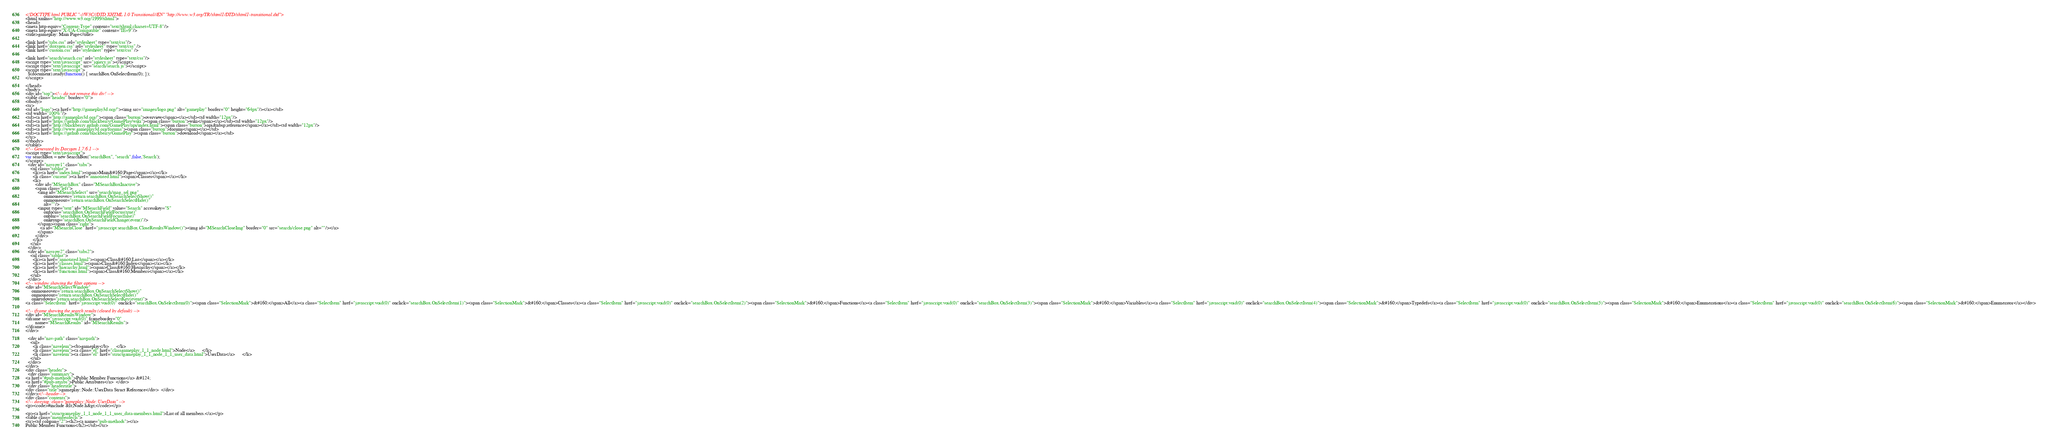Convert code to text. <code><loc_0><loc_0><loc_500><loc_500><_HTML_><!DOCTYPE html PUBLIC "-//W3C//DTD XHTML 1.0 Transitional//EN" "http://www.w3.org/TR/xhtml1/DTD/xhtml1-transitional.dtd">
<html xmlns="http://www.w3.org/1999/xhtml">
<head>
<meta http-equiv="Content-Type" content="text/xhtml;charset=UTF-8"/>
<meta http-equiv="X-UA-Compatible" content="IE=9"/>
<title>gameplay: Main Page</title>

<link href="tabs.css" rel="stylesheet" type="text/css"/>
<link href="doxygen.css" rel="stylesheet" type="text/css" />
<link href="custom.css" rel="stylesheet" type="text/css" />

<link href="search/search.css" rel="stylesheet" type="text/css"/>
<script type="text/javascript" src="jquery.js"></script>
<script type="text/javascript" src="search/search.js"></script>
<script type="text/javascript">
  $(document).ready(function() { searchBox.OnSelectItem(0); });
</script>

</head>
<body>
<div id="top"><!-- do not remove this div! -->
<table class="header" border="0">
<tbody>
<tr>
<td id="logo"><a href="http://gameplay3d.org/"><img src="images/logo.png" alt="gameplay" border="0" height="64px"/></a></td>
<td width="100%"/>
<td><a href="http://gameplay3d.org/"><span class="button">overview</span></a></td><td width="12px"/>
<td><a href="https://github.com/blackberry/GamePlay/wiki"><span class="button">wiki</span></a></td><td width="12px"/>
<td><a href="http://blackberry.github.com/GamePlay/api/index.html"><span class="button">api&nbsp;reference</span></a></td><td width="12px"/>
<td><a href="http://www.gameplay3d.org/forums"><span class="button">forums</span></a></td>
<td><a href="https://github.com/blackberry/GamePlay"><span class="button">download</span></a></td>
</tr>
</tbody>
</table>
<!-- Generated by Doxygen 1.7.6.1 -->
<script type="text/javascript">
var searchBox = new SearchBox("searchBox", "search",false,'Search');
</script>
  <div id="navrow1" class="tabs">
    <ul class="tablist">
      <li><a href="index.html"><span>Main&#160;Page</span></a></li>
      <li class="current"><a href="annotated.html"><span>Classes</span></a></li>
      <li>
        <div id="MSearchBox" class="MSearchBoxInactive">
        <span class="left">
          <img id="MSearchSelect" src="search/mag_sel.png"
               onmouseover="return searchBox.OnSearchSelectShow()"
               onmouseout="return searchBox.OnSearchSelectHide()"
               alt=""/>
          <input type="text" id="MSearchField" value="Search" accesskey="S"
               onfocus="searchBox.OnSearchFieldFocus(true)" 
               onblur="searchBox.OnSearchFieldFocus(false)" 
               onkeyup="searchBox.OnSearchFieldChange(event)"/>
          </span><span class="right">
            <a id="MSearchClose" href="javascript:searchBox.CloseResultsWindow()"><img id="MSearchCloseImg" border="0" src="search/close.png" alt=""/></a>
          </span>
        </div>
      </li>
    </ul>
  </div>
  <div id="navrow2" class="tabs2">
    <ul class="tablist">
      <li><a href="annotated.html"><span>Class&#160;List</span></a></li>
      <li><a href="classes.html"><span>Class&#160;Index</span></a></li>
      <li><a href="hierarchy.html"><span>Class&#160;Hierarchy</span></a></li>
      <li><a href="functions.html"><span>Class&#160;Members</span></a></li>
    </ul>
  </div>
<!-- window showing the filter options -->
<div id="MSearchSelectWindow"
     onmouseover="return searchBox.OnSearchSelectShow()"
     onmouseout="return searchBox.OnSearchSelectHide()"
     onkeydown="return searchBox.OnSearchSelectKey(event)">
<a class="SelectItem" href="javascript:void(0)" onclick="searchBox.OnSelectItem(0)"><span class="SelectionMark">&#160;</span>All</a><a class="SelectItem" href="javascript:void(0)" onclick="searchBox.OnSelectItem(1)"><span class="SelectionMark">&#160;</span>Classes</a><a class="SelectItem" href="javascript:void(0)" onclick="searchBox.OnSelectItem(2)"><span class="SelectionMark">&#160;</span>Functions</a><a class="SelectItem" href="javascript:void(0)" onclick="searchBox.OnSelectItem(3)"><span class="SelectionMark">&#160;</span>Variables</a><a class="SelectItem" href="javascript:void(0)" onclick="searchBox.OnSelectItem(4)"><span class="SelectionMark">&#160;</span>Typedefs</a><a class="SelectItem" href="javascript:void(0)" onclick="searchBox.OnSelectItem(5)"><span class="SelectionMark">&#160;</span>Enumerations</a><a class="SelectItem" href="javascript:void(0)" onclick="searchBox.OnSelectItem(6)"><span class="SelectionMark">&#160;</span>Enumerator</a></div>

<!-- iframe showing the search results (closed by default) -->
<div id="MSearchResultsWindow">
<iframe src="javascript:void(0)" frameborder="0" 
        name="MSearchResults" id="MSearchResults">
</iframe>
</div>

  <div id="nav-path" class="navpath">
    <ul>
      <li class="navelem"><b>gameplay</b>      </li>
      <li class="navelem"><a class="el" href="classgameplay_1_1_node.html">Node</a>      </li>
      <li class="navelem"><a class="el" href="structgameplay_1_1_node_1_1_user_data.html">UserData</a>      </li>
    </ul>
  </div>
</div>
<div class="header">
  <div class="summary">
<a href="#pub-methods">Public Member Functions</a> &#124;
<a href="#pub-attribs">Public Attributes</a>  </div>
  <div class="headertitle">
<div class="title">gameplay::Node::UserData Struct Reference</div>  </div>
</div><!--header-->
<div class="contents">
<!-- doxytag: class="gameplay::Node::UserData" -->
<p><code>#include &lt;Node.h&gt;</code></p>

<p><a href="structgameplay_1_1_node_1_1_user_data-members.html">List of all members.</a></p>
<table class="memberdecls">
<tr><td colspan="2"><h2><a name="pub-methods"></a>
Public Member Functions</h2></td></tr></code> 